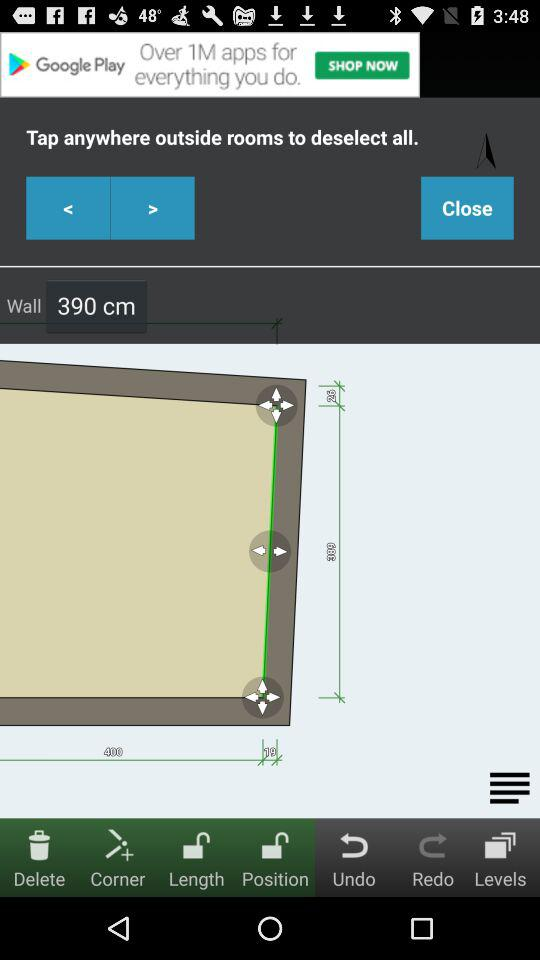What is the wall height? The wall height is 390 cm. 